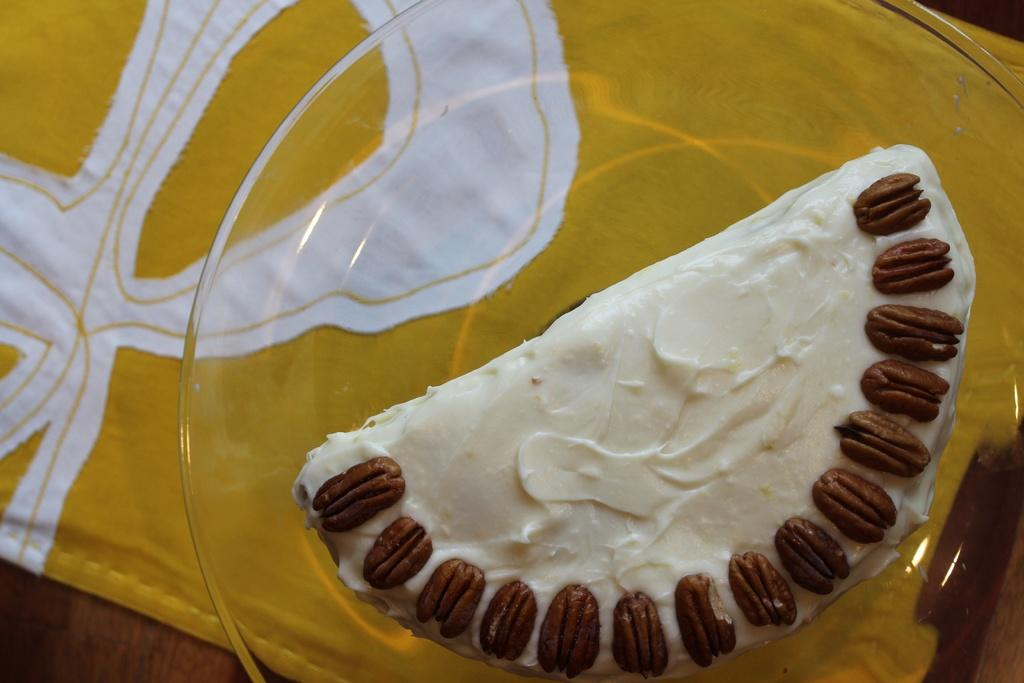What piece of furniture is present in the image? There is a table in the image. What is covering the table? There is a cloth on the table. What object is placed on the table? There is a plate on the table. What is on the plate? The plate contains a food item. What type of wine is being served from the plate in the image? There is no wine present in the image; the plate contains a food item. How does the nose contribute to the journey of the food item in the image? The image does not depict a nose or any journey related to the food item. 